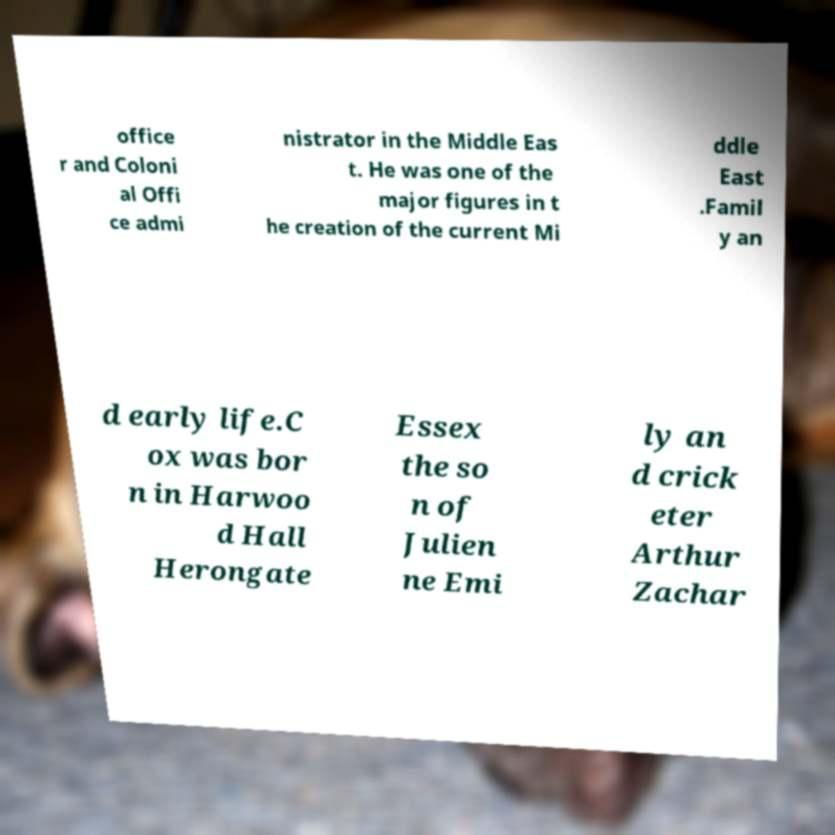Can you read and provide the text displayed in the image?This photo seems to have some interesting text. Can you extract and type it out for me? office r and Coloni al Offi ce admi nistrator in the Middle Eas t. He was one of the major figures in t he creation of the current Mi ddle East .Famil y an d early life.C ox was bor n in Harwoo d Hall Herongate Essex the so n of Julien ne Emi ly an d crick eter Arthur Zachar 